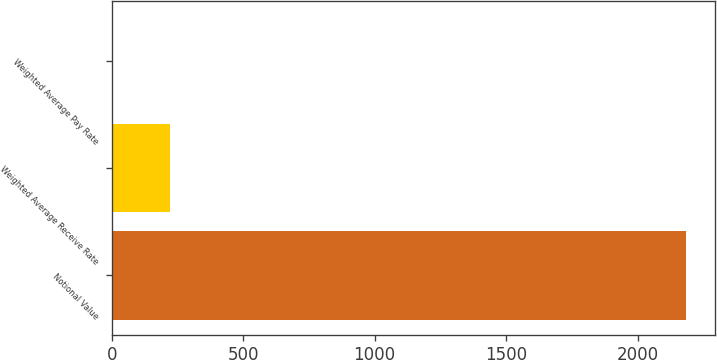Convert chart. <chart><loc_0><loc_0><loc_500><loc_500><bar_chart><fcel>Notional Value<fcel>Weighted Average Receive Rate<fcel>Weighted Average Pay Rate<nl><fcel>2185<fcel>223.45<fcel>5.5<nl></chart> 